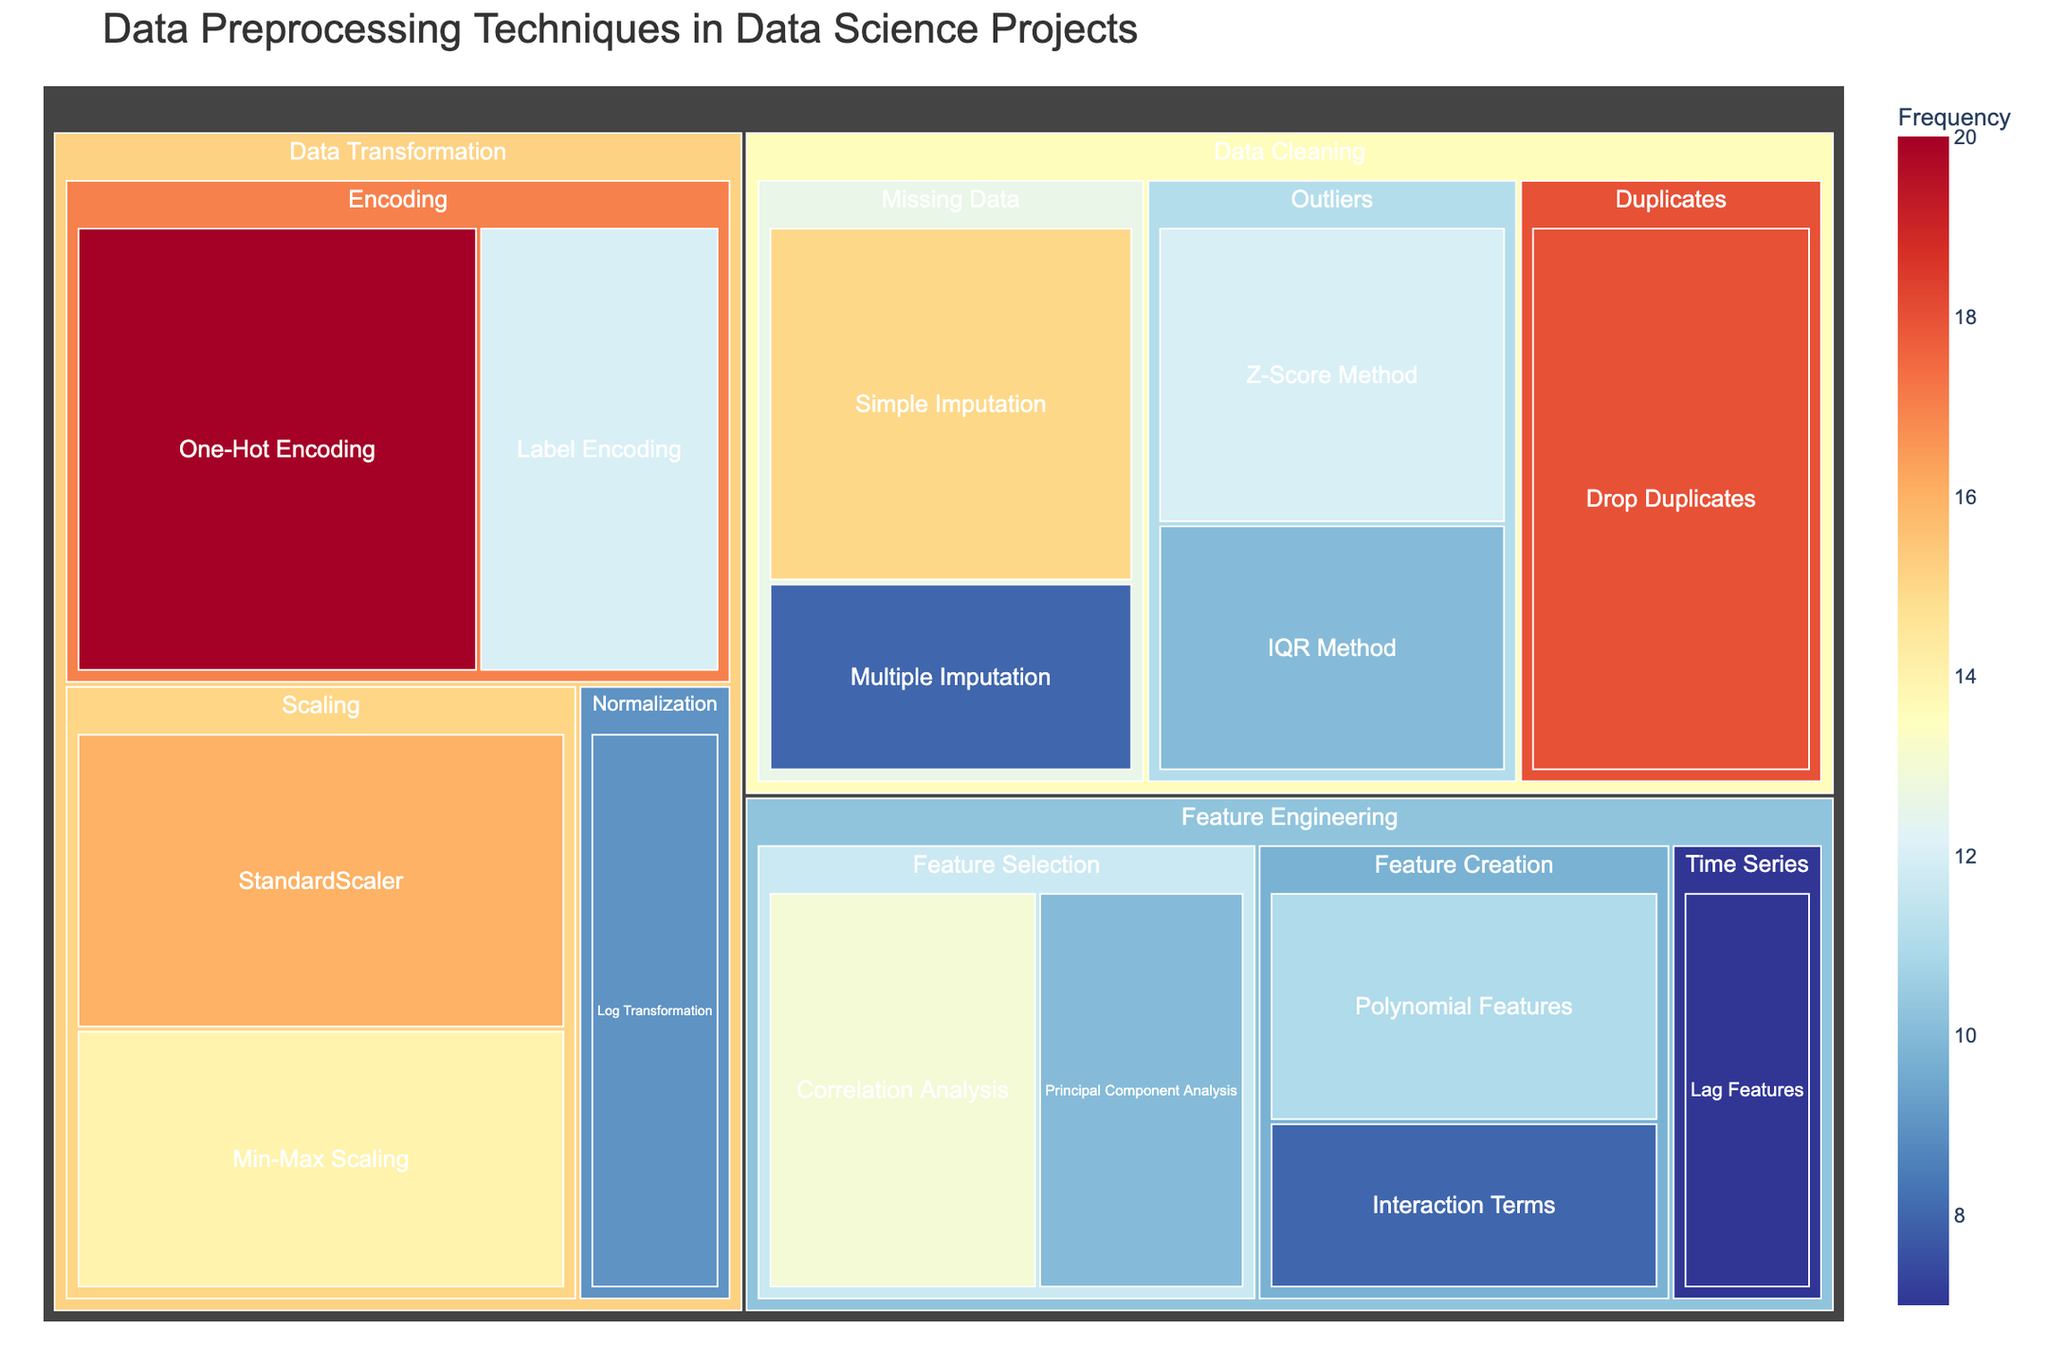what is the title of the treemap? The title is displayed at the top of the treemap. It summarizes the content being visualized.
Answer: Data Preprocessing Techniques in Data Science Projects Which category has the highest value? Add up values for each category (Data Cleaning, Data Transformation, and Feature Engineering) and compare. Data Cleaning: 63, Data Transformation: 71, Feature Engineering: 49.
Answer: Data Transformation Which technique is the most frequently used? Locate the technique with the highest value across all subcategories. "One-Hot Encoding" in Data Transformation has the highest value of 20.
Answer: One-Hot Encoding Compare the frequency of the Z-Score Method and the IQR Method. Which one is higher? Find the values for both "Z-Score Method" (12) and "IQR Method" (10) in the Data Cleaning category under Outliers.
Answer: Z-Score Method How does the frequency of Simple Imputation compare to Multiple Imputation? Find the values for both "Simple Imputation" (15) and "Multiple Imputation" (8) in the Data Cleaning category under Missing Data.
Answer: Simple Imputation What is the total value for Feature Selection techniques? Sum the values for "Correlation Analysis" (13) and "Principal Component Analysis" (10) under Feature Engineering.
Answer: 23 In the Data Cleaning category, which sub-category has the least value? Compare values for each subcategory in Data Cleaning: Missing Data (23), Outliers (22), Duplicates (18).
Answer: Duplicates Which subcategory in Data Transformation has the highest value? Compare the values for subcategories in Data Transformation: Scaling (30), Encoding (32), Normalization (9).
Answer: Encoding What is the difference between the total values of Scaling and Feature Creation techniques? Sum the values: Scaling (14+16=30), Feature Creation (11+8=19); then calculate the difference (30-19).
Answer: 11 What is the total frequency of techniques used in Outliers detection? Sum the values for "Z-Score Method" (12) and "IQR Method" (10) under Outliers in Data Cleaning.
Answer: 22 